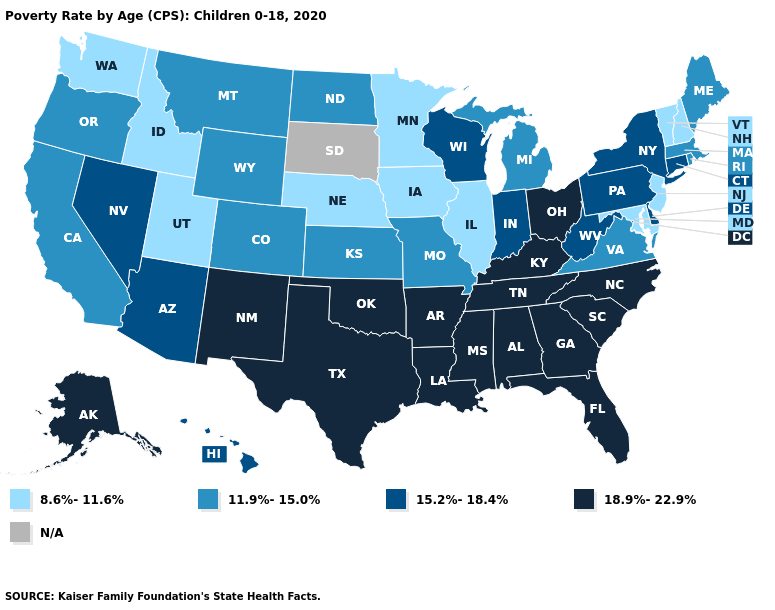What is the value of Maryland?
Give a very brief answer. 8.6%-11.6%. What is the highest value in states that border South Dakota?
Write a very short answer. 11.9%-15.0%. What is the value of South Dakota?
Write a very short answer. N/A. What is the value of Hawaii?
Short answer required. 15.2%-18.4%. Name the states that have a value in the range 15.2%-18.4%?
Be succinct. Arizona, Connecticut, Delaware, Hawaii, Indiana, Nevada, New York, Pennsylvania, West Virginia, Wisconsin. Is the legend a continuous bar?
Be succinct. No. Among the states that border Michigan , does Wisconsin have the highest value?
Be succinct. No. Does the first symbol in the legend represent the smallest category?
Quick response, please. Yes. How many symbols are there in the legend?
Keep it brief. 5. What is the value of Kentucky?
Be succinct. 18.9%-22.9%. What is the highest value in the USA?
Be succinct. 18.9%-22.9%. What is the lowest value in the USA?
Answer briefly. 8.6%-11.6%. Does Tennessee have the highest value in the USA?
Short answer required. Yes. Does Idaho have the lowest value in the USA?
Answer briefly. Yes. What is the value of Indiana?
Answer briefly. 15.2%-18.4%. 